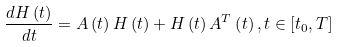<formula> <loc_0><loc_0><loc_500><loc_500>\frac { d H \left ( t \right ) } { d t } = A \left ( t \right ) H \left ( t \right ) + H \left ( t \right ) A ^ { T } \left ( t \right ) , t \in \left [ t _ { 0 } , T \right ]</formula> 